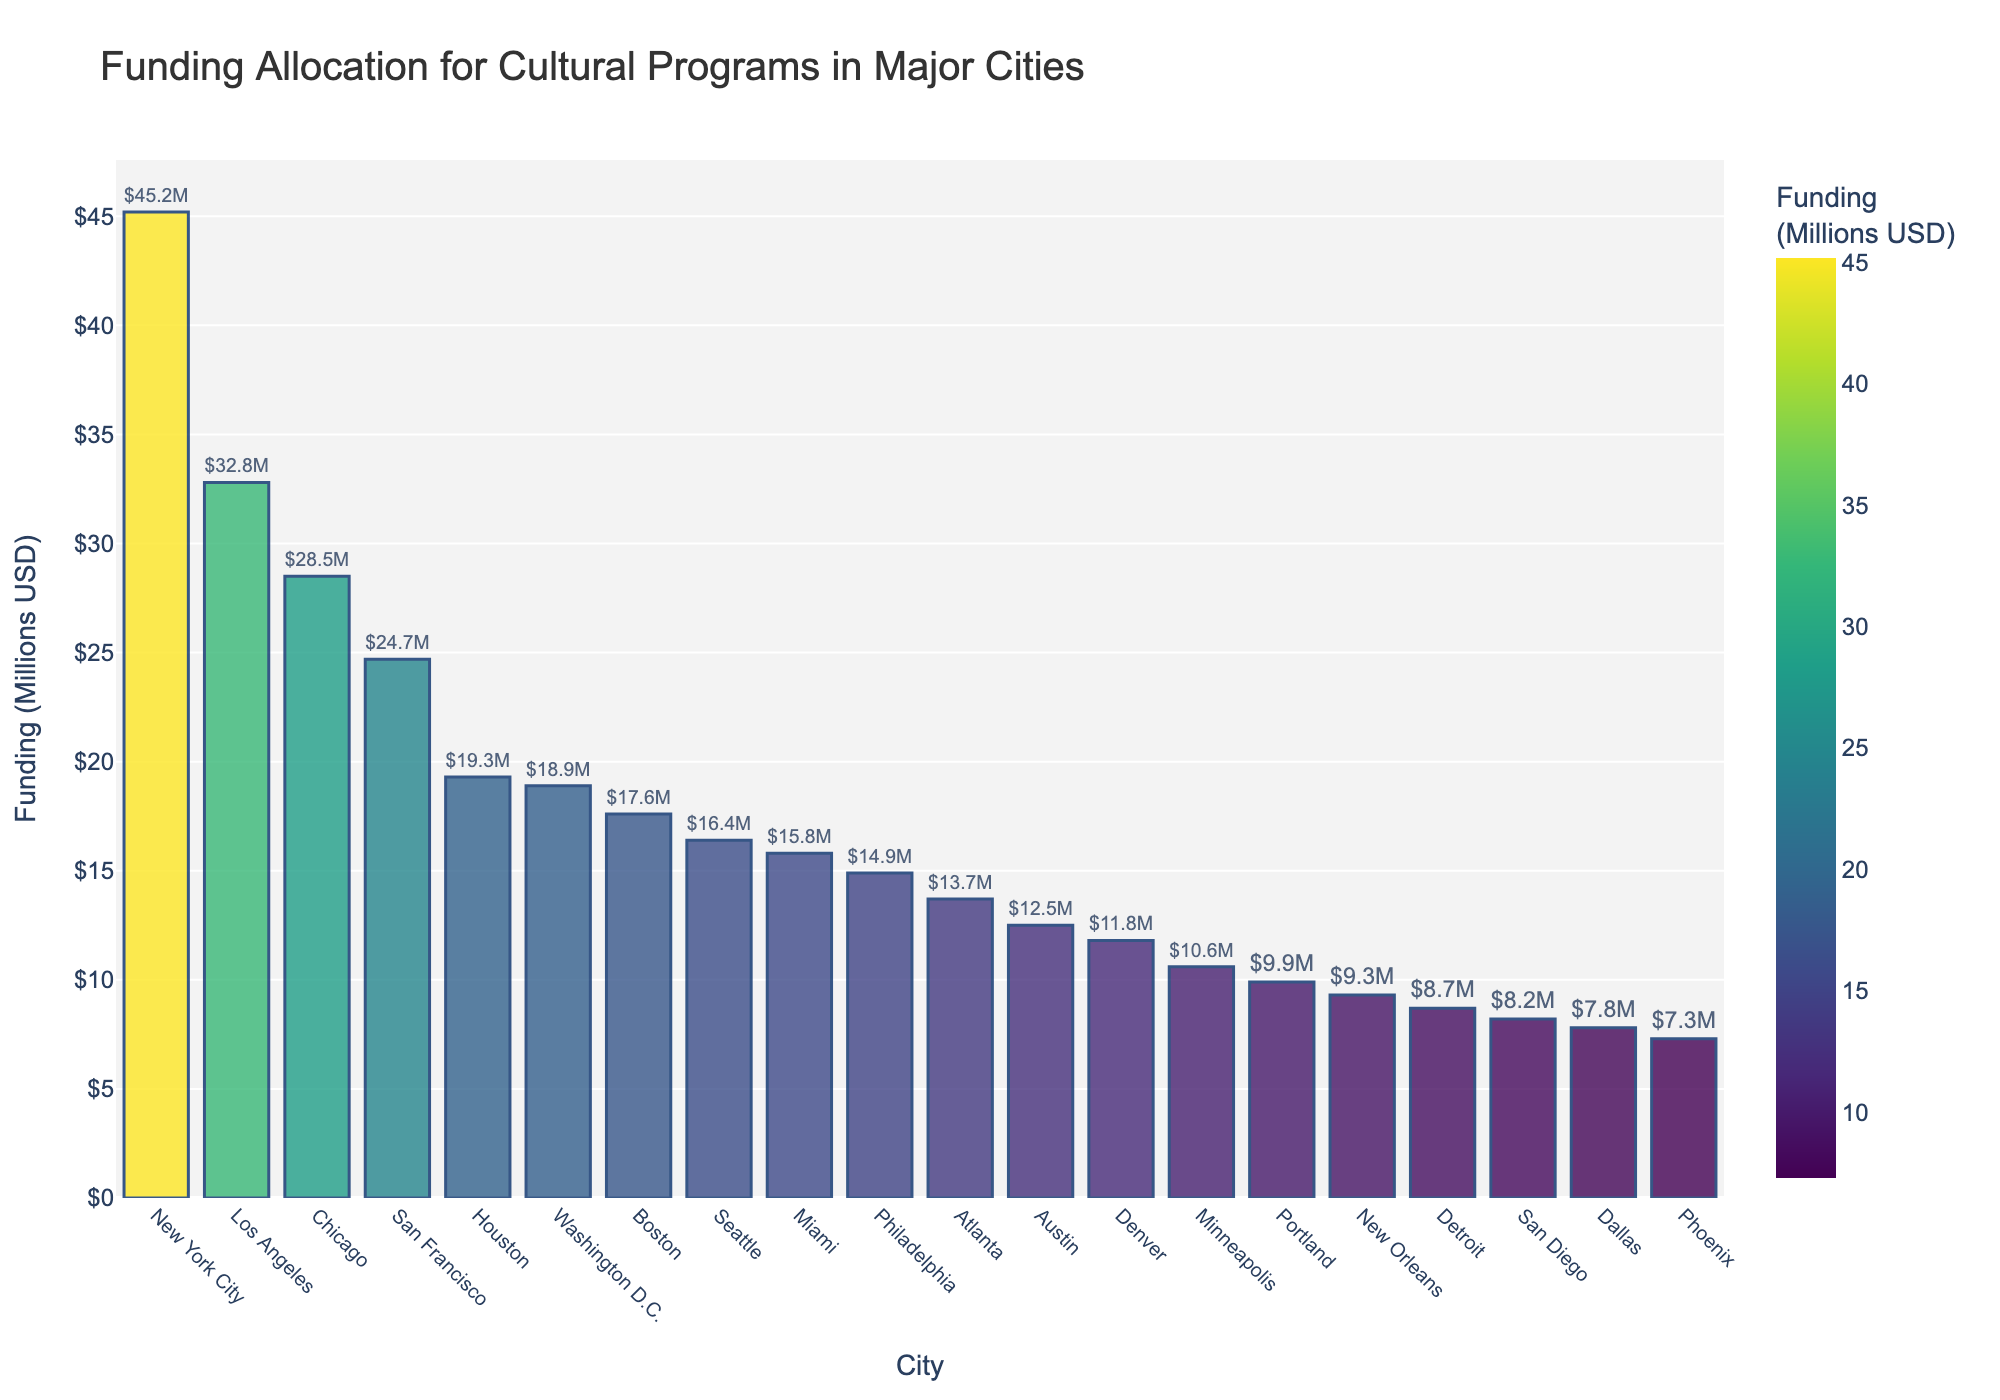Which city has the highest funding allocation for cultural programs? To find the city with the highest funding, look for the tallest bar on the plot. New York City has the tallest bar.
Answer: New York City Which two cities have the closest funding allocations? To determine cities with close funding, observe bars that are close in height. Denver ($11.8M) and Minneapolis ($10.6M) appear to have close funding values.
Answer: Denver and Minneapolis How much more funding does New York City have compared to Los Angeles? First, identify the funding for both cities; New York City ($45.2M) and Los Angeles ($32.8M). Calculate the difference: $45.2M - $32.8M.
Answer: $12.4M What is the combined funding allocation for Boston and Seattle? Add the funding amounts for Boston ($17.6M) and Seattle ($16.4M): $17.6M + $16.4M.
Answer: $34M Which city has the lowest funding, and how much less is it than San Francisco's funding? Find the lowest bar corresponding to Phoenix ($7.3M). Compare it with San Francisco ($24.7M): $24.7M - $7.3M.
Answer: Phoenix, $17.4M What is the average funding allocation of the top three cities? The top three cities are New York City ($45.2M), Los Angeles ($32.8M), and Chicago ($28.5M). Compute the average: ($45.2M + $32.8M + $28.5M) / 3.
Answer: $35.5M Is there a city with exactly half the funding of Houston? Houston has $19.3M. Half of that is $19.3M / 2 = $9.65M. No city in the dataset has this exact amount.
Answer: No What is the range of the funding allocations? First, identify the highest ($45.2M, New York City) and lowest ($7.3M, Phoenix) funding amounts. Calculate the range: $45.2M - $7.3M.
Answer: $37.9M How do Miami's and Philadelphia's funding allocations compare visually in terms of bar height? Both cities have bars of similar, though slightly different heights. Miami has $15.8M and Philadelphia has $14.9M, indicating they are close in funding.
Answer: Close, with Miami slightly higher What is the total funding allocation for all cities combined? Sum the funding values for all cities: $45.2M + $32.8M + $28.5M + $24.7M + $19.3M + $18.9M + $17.6M + $16.4M + $15.8M + $14.9M + $13.7M + $12.5M + $11.8M + $10.6M + $9.9M + $9.3M + $8.7M + $8.2M + $7.8M + $7.3M = $354M
Answer: $354M 